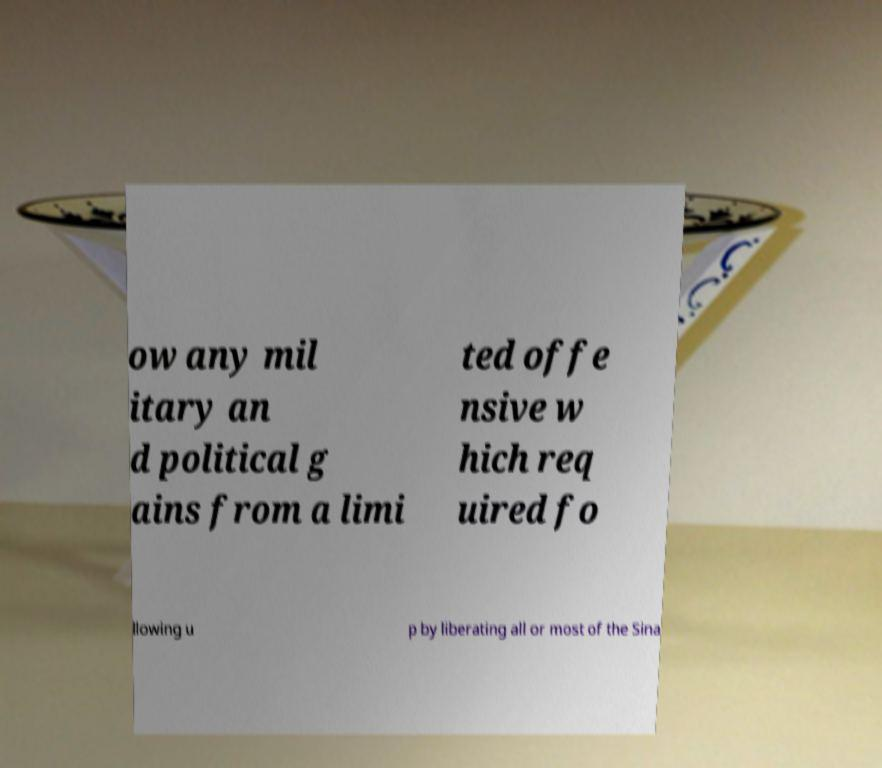I need the written content from this picture converted into text. Can you do that? ow any mil itary an d political g ains from a limi ted offe nsive w hich req uired fo llowing u p by liberating all or most of the Sina 